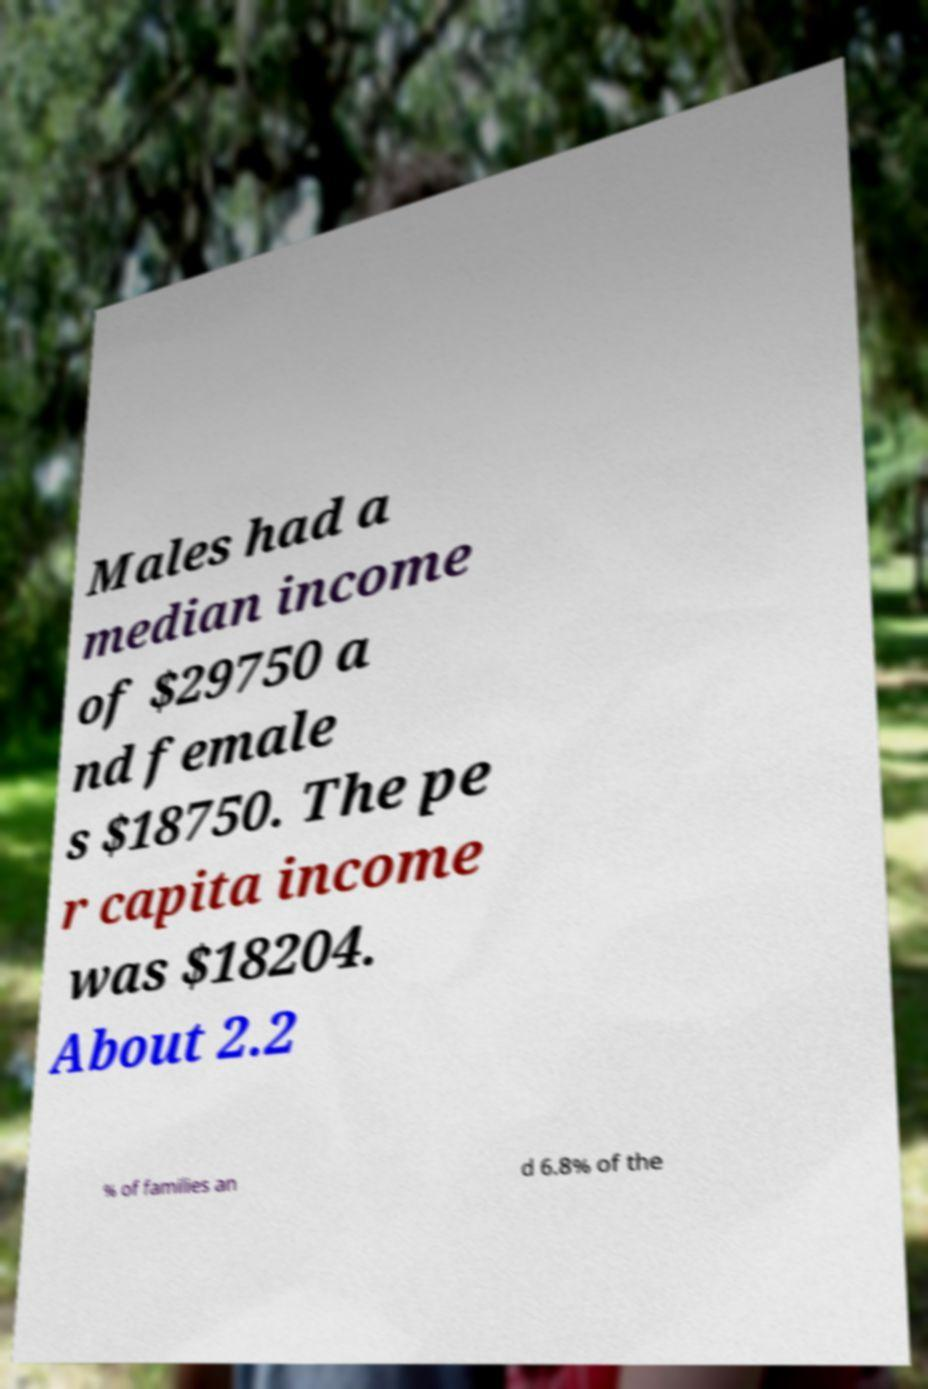For documentation purposes, I need the text within this image transcribed. Could you provide that? Males had a median income of $29750 a nd female s $18750. The pe r capita income was $18204. About 2.2 % of families an d 6.8% of the 